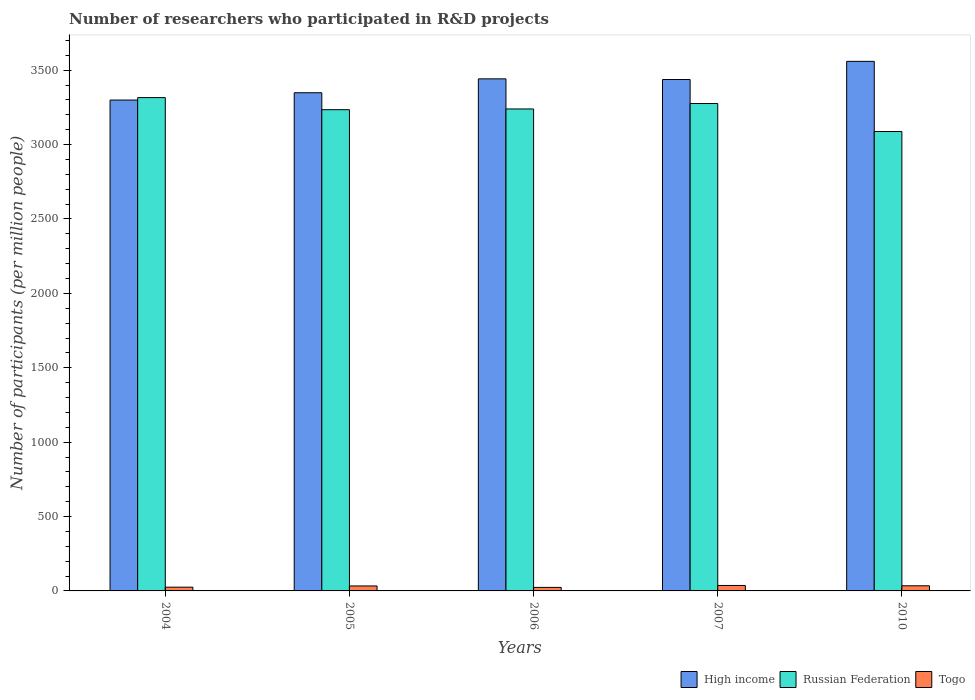How many different coloured bars are there?
Provide a succinct answer. 3. How many groups of bars are there?
Make the answer very short. 5. How many bars are there on the 5th tick from the left?
Give a very brief answer. 3. What is the label of the 1st group of bars from the left?
Make the answer very short. 2004. In how many cases, is the number of bars for a given year not equal to the number of legend labels?
Make the answer very short. 0. What is the number of researchers who participated in R&D projects in High income in 2006?
Provide a short and direct response. 3442.03. Across all years, what is the maximum number of researchers who participated in R&D projects in Togo?
Provide a short and direct response. 36.67. Across all years, what is the minimum number of researchers who participated in R&D projects in High income?
Keep it short and to the point. 3299.61. In which year was the number of researchers who participated in R&D projects in High income maximum?
Provide a short and direct response. 2010. In which year was the number of researchers who participated in R&D projects in Russian Federation minimum?
Provide a short and direct response. 2010. What is the total number of researchers who participated in R&D projects in Russian Federation in the graph?
Give a very brief answer. 1.62e+04. What is the difference between the number of researchers who participated in R&D projects in Togo in 2007 and that in 2010?
Provide a short and direct response. 2.2. What is the difference between the number of researchers who participated in R&D projects in Russian Federation in 2010 and the number of researchers who participated in R&D projects in High income in 2004?
Your answer should be compact. -211.62. What is the average number of researchers who participated in R&D projects in Russian Federation per year?
Your answer should be very brief. 3230.88. In the year 2004, what is the difference between the number of researchers who participated in R&D projects in Russian Federation and number of researchers who participated in R&D projects in Togo?
Give a very brief answer. 3290.74. What is the ratio of the number of researchers who participated in R&D projects in Togo in 2007 to that in 2010?
Keep it short and to the point. 1.06. What is the difference between the highest and the second highest number of researchers who participated in R&D projects in High income?
Offer a very short reply. 117.57. What is the difference between the highest and the lowest number of researchers who participated in R&D projects in High income?
Offer a terse response. 259.99. Is the sum of the number of researchers who participated in R&D projects in Russian Federation in 2005 and 2007 greater than the maximum number of researchers who participated in R&D projects in High income across all years?
Give a very brief answer. Yes. What does the 3rd bar from the left in 2004 represents?
Your answer should be very brief. Togo. Is it the case that in every year, the sum of the number of researchers who participated in R&D projects in High income and number of researchers who participated in R&D projects in Russian Federation is greater than the number of researchers who participated in R&D projects in Togo?
Provide a short and direct response. Yes. How many bars are there?
Offer a very short reply. 15. How many years are there in the graph?
Your answer should be compact. 5. What is the difference between two consecutive major ticks on the Y-axis?
Give a very brief answer. 500. Are the values on the major ticks of Y-axis written in scientific E-notation?
Your answer should be compact. No. How many legend labels are there?
Keep it short and to the point. 3. How are the legend labels stacked?
Your answer should be very brief. Horizontal. What is the title of the graph?
Your answer should be compact. Number of researchers who participated in R&D projects. Does "Pacific island small states" appear as one of the legend labels in the graph?
Provide a succinct answer. No. What is the label or title of the Y-axis?
Offer a terse response. Number of participants (per million people). What is the Number of participants (per million people) of High income in 2004?
Give a very brief answer. 3299.61. What is the Number of participants (per million people) in Russian Federation in 2004?
Your response must be concise. 3315.98. What is the Number of participants (per million people) of Togo in 2004?
Offer a terse response. 25.24. What is the Number of participants (per million people) of High income in 2005?
Your answer should be compact. 3348.65. What is the Number of participants (per million people) of Russian Federation in 2005?
Your answer should be very brief. 3234.71. What is the Number of participants (per million people) in Togo in 2005?
Keep it short and to the point. 33.34. What is the Number of participants (per million people) in High income in 2006?
Offer a very short reply. 3442.03. What is the Number of participants (per million people) in Russian Federation in 2006?
Give a very brief answer. 3239.59. What is the Number of participants (per million people) of Togo in 2006?
Offer a terse response. 23.73. What is the Number of participants (per million people) of High income in 2007?
Offer a very short reply. 3437.47. What is the Number of participants (per million people) of Russian Federation in 2007?
Ensure brevity in your answer.  3276.12. What is the Number of participants (per million people) of Togo in 2007?
Offer a very short reply. 36.67. What is the Number of participants (per million people) of High income in 2010?
Ensure brevity in your answer.  3559.6. What is the Number of participants (per million people) of Russian Federation in 2010?
Keep it short and to the point. 3087.99. What is the Number of participants (per million people) in Togo in 2010?
Offer a very short reply. 34.47. Across all years, what is the maximum Number of participants (per million people) in High income?
Your response must be concise. 3559.6. Across all years, what is the maximum Number of participants (per million people) of Russian Federation?
Your response must be concise. 3315.98. Across all years, what is the maximum Number of participants (per million people) of Togo?
Give a very brief answer. 36.67. Across all years, what is the minimum Number of participants (per million people) of High income?
Make the answer very short. 3299.61. Across all years, what is the minimum Number of participants (per million people) in Russian Federation?
Offer a very short reply. 3087.99. Across all years, what is the minimum Number of participants (per million people) of Togo?
Keep it short and to the point. 23.73. What is the total Number of participants (per million people) in High income in the graph?
Make the answer very short. 1.71e+04. What is the total Number of participants (per million people) of Russian Federation in the graph?
Give a very brief answer. 1.62e+04. What is the total Number of participants (per million people) in Togo in the graph?
Make the answer very short. 153.45. What is the difference between the Number of participants (per million people) in High income in 2004 and that in 2005?
Offer a terse response. -49.04. What is the difference between the Number of participants (per million people) of Russian Federation in 2004 and that in 2005?
Give a very brief answer. 81.27. What is the difference between the Number of participants (per million people) of Togo in 2004 and that in 2005?
Make the answer very short. -8.11. What is the difference between the Number of participants (per million people) in High income in 2004 and that in 2006?
Your answer should be compact. -142.42. What is the difference between the Number of participants (per million people) in Russian Federation in 2004 and that in 2006?
Keep it short and to the point. 76.4. What is the difference between the Number of participants (per million people) of Togo in 2004 and that in 2006?
Give a very brief answer. 1.51. What is the difference between the Number of participants (per million people) in High income in 2004 and that in 2007?
Ensure brevity in your answer.  -137.86. What is the difference between the Number of participants (per million people) in Russian Federation in 2004 and that in 2007?
Give a very brief answer. 39.86. What is the difference between the Number of participants (per million people) in Togo in 2004 and that in 2007?
Make the answer very short. -11.43. What is the difference between the Number of participants (per million people) of High income in 2004 and that in 2010?
Your response must be concise. -259.99. What is the difference between the Number of participants (per million people) of Russian Federation in 2004 and that in 2010?
Ensure brevity in your answer.  227.99. What is the difference between the Number of participants (per million people) of Togo in 2004 and that in 2010?
Your answer should be very brief. -9.23. What is the difference between the Number of participants (per million people) in High income in 2005 and that in 2006?
Offer a terse response. -93.37. What is the difference between the Number of participants (per million people) in Russian Federation in 2005 and that in 2006?
Your response must be concise. -4.88. What is the difference between the Number of participants (per million people) in Togo in 2005 and that in 2006?
Provide a short and direct response. 9.62. What is the difference between the Number of participants (per million people) of High income in 2005 and that in 2007?
Make the answer very short. -88.82. What is the difference between the Number of participants (per million people) of Russian Federation in 2005 and that in 2007?
Offer a very short reply. -41.41. What is the difference between the Number of participants (per million people) in Togo in 2005 and that in 2007?
Offer a terse response. -3.33. What is the difference between the Number of participants (per million people) in High income in 2005 and that in 2010?
Your answer should be compact. -210.95. What is the difference between the Number of participants (per million people) of Russian Federation in 2005 and that in 2010?
Ensure brevity in your answer.  146.72. What is the difference between the Number of participants (per million people) of Togo in 2005 and that in 2010?
Offer a terse response. -1.13. What is the difference between the Number of participants (per million people) of High income in 2006 and that in 2007?
Offer a very short reply. 4.56. What is the difference between the Number of participants (per million people) of Russian Federation in 2006 and that in 2007?
Your answer should be very brief. -36.54. What is the difference between the Number of participants (per million people) in Togo in 2006 and that in 2007?
Ensure brevity in your answer.  -12.94. What is the difference between the Number of participants (per million people) of High income in 2006 and that in 2010?
Your response must be concise. -117.57. What is the difference between the Number of participants (per million people) in Russian Federation in 2006 and that in 2010?
Offer a terse response. 151.59. What is the difference between the Number of participants (per million people) in Togo in 2006 and that in 2010?
Provide a short and direct response. -10.75. What is the difference between the Number of participants (per million people) of High income in 2007 and that in 2010?
Offer a very short reply. -122.13. What is the difference between the Number of participants (per million people) in Russian Federation in 2007 and that in 2010?
Ensure brevity in your answer.  188.13. What is the difference between the Number of participants (per million people) of Togo in 2007 and that in 2010?
Provide a succinct answer. 2.2. What is the difference between the Number of participants (per million people) of High income in 2004 and the Number of participants (per million people) of Russian Federation in 2005?
Your answer should be compact. 64.9. What is the difference between the Number of participants (per million people) in High income in 2004 and the Number of participants (per million people) in Togo in 2005?
Provide a short and direct response. 3266.27. What is the difference between the Number of participants (per million people) of Russian Federation in 2004 and the Number of participants (per million people) of Togo in 2005?
Ensure brevity in your answer.  3282.64. What is the difference between the Number of participants (per million people) of High income in 2004 and the Number of participants (per million people) of Russian Federation in 2006?
Ensure brevity in your answer.  60.03. What is the difference between the Number of participants (per million people) of High income in 2004 and the Number of participants (per million people) of Togo in 2006?
Offer a very short reply. 3275.89. What is the difference between the Number of participants (per million people) in Russian Federation in 2004 and the Number of participants (per million people) in Togo in 2006?
Ensure brevity in your answer.  3292.26. What is the difference between the Number of participants (per million people) in High income in 2004 and the Number of participants (per million people) in Russian Federation in 2007?
Ensure brevity in your answer.  23.49. What is the difference between the Number of participants (per million people) of High income in 2004 and the Number of participants (per million people) of Togo in 2007?
Ensure brevity in your answer.  3262.94. What is the difference between the Number of participants (per million people) of Russian Federation in 2004 and the Number of participants (per million people) of Togo in 2007?
Ensure brevity in your answer.  3279.31. What is the difference between the Number of participants (per million people) in High income in 2004 and the Number of participants (per million people) in Russian Federation in 2010?
Make the answer very short. 211.62. What is the difference between the Number of participants (per million people) of High income in 2004 and the Number of participants (per million people) of Togo in 2010?
Offer a terse response. 3265.14. What is the difference between the Number of participants (per million people) of Russian Federation in 2004 and the Number of participants (per million people) of Togo in 2010?
Make the answer very short. 3281.51. What is the difference between the Number of participants (per million people) of High income in 2005 and the Number of participants (per million people) of Russian Federation in 2006?
Your answer should be very brief. 109.07. What is the difference between the Number of participants (per million people) in High income in 2005 and the Number of participants (per million people) in Togo in 2006?
Ensure brevity in your answer.  3324.93. What is the difference between the Number of participants (per million people) in Russian Federation in 2005 and the Number of participants (per million people) in Togo in 2006?
Keep it short and to the point. 3210.98. What is the difference between the Number of participants (per million people) of High income in 2005 and the Number of participants (per million people) of Russian Federation in 2007?
Your response must be concise. 72.53. What is the difference between the Number of participants (per million people) of High income in 2005 and the Number of participants (per million people) of Togo in 2007?
Make the answer very short. 3311.98. What is the difference between the Number of participants (per million people) of Russian Federation in 2005 and the Number of participants (per million people) of Togo in 2007?
Your answer should be very brief. 3198.04. What is the difference between the Number of participants (per million people) of High income in 2005 and the Number of participants (per million people) of Russian Federation in 2010?
Keep it short and to the point. 260.66. What is the difference between the Number of participants (per million people) in High income in 2005 and the Number of participants (per million people) in Togo in 2010?
Provide a short and direct response. 3314.18. What is the difference between the Number of participants (per million people) of Russian Federation in 2005 and the Number of participants (per million people) of Togo in 2010?
Make the answer very short. 3200.24. What is the difference between the Number of participants (per million people) in High income in 2006 and the Number of participants (per million people) in Russian Federation in 2007?
Offer a terse response. 165.9. What is the difference between the Number of participants (per million people) in High income in 2006 and the Number of participants (per million people) in Togo in 2007?
Your answer should be very brief. 3405.36. What is the difference between the Number of participants (per million people) in Russian Federation in 2006 and the Number of participants (per million people) in Togo in 2007?
Your answer should be compact. 3202.92. What is the difference between the Number of participants (per million people) of High income in 2006 and the Number of participants (per million people) of Russian Federation in 2010?
Provide a succinct answer. 354.03. What is the difference between the Number of participants (per million people) of High income in 2006 and the Number of participants (per million people) of Togo in 2010?
Ensure brevity in your answer.  3407.56. What is the difference between the Number of participants (per million people) in Russian Federation in 2006 and the Number of participants (per million people) in Togo in 2010?
Provide a short and direct response. 3205.11. What is the difference between the Number of participants (per million people) in High income in 2007 and the Number of participants (per million people) in Russian Federation in 2010?
Your answer should be very brief. 349.48. What is the difference between the Number of participants (per million people) in High income in 2007 and the Number of participants (per million people) in Togo in 2010?
Ensure brevity in your answer.  3403. What is the difference between the Number of participants (per million people) of Russian Federation in 2007 and the Number of participants (per million people) of Togo in 2010?
Make the answer very short. 3241.65. What is the average Number of participants (per million people) of High income per year?
Ensure brevity in your answer.  3417.47. What is the average Number of participants (per million people) of Russian Federation per year?
Your answer should be very brief. 3230.88. What is the average Number of participants (per million people) of Togo per year?
Your answer should be very brief. 30.69. In the year 2004, what is the difference between the Number of participants (per million people) in High income and Number of participants (per million people) in Russian Federation?
Provide a succinct answer. -16.37. In the year 2004, what is the difference between the Number of participants (per million people) in High income and Number of participants (per million people) in Togo?
Give a very brief answer. 3274.37. In the year 2004, what is the difference between the Number of participants (per million people) of Russian Federation and Number of participants (per million people) of Togo?
Provide a succinct answer. 3290.74. In the year 2005, what is the difference between the Number of participants (per million people) in High income and Number of participants (per million people) in Russian Federation?
Provide a succinct answer. 113.95. In the year 2005, what is the difference between the Number of participants (per million people) of High income and Number of participants (per million people) of Togo?
Offer a terse response. 3315.31. In the year 2005, what is the difference between the Number of participants (per million people) in Russian Federation and Number of participants (per million people) in Togo?
Offer a terse response. 3201.36. In the year 2006, what is the difference between the Number of participants (per million people) in High income and Number of participants (per million people) in Russian Federation?
Provide a short and direct response. 202.44. In the year 2006, what is the difference between the Number of participants (per million people) of High income and Number of participants (per million people) of Togo?
Provide a succinct answer. 3418.3. In the year 2006, what is the difference between the Number of participants (per million people) of Russian Federation and Number of participants (per million people) of Togo?
Provide a succinct answer. 3215.86. In the year 2007, what is the difference between the Number of participants (per million people) of High income and Number of participants (per million people) of Russian Federation?
Your response must be concise. 161.35. In the year 2007, what is the difference between the Number of participants (per million people) of High income and Number of participants (per million people) of Togo?
Keep it short and to the point. 3400.8. In the year 2007, what is the difference between the Number of participants (per million people) of Russian Federation and Number of participants (per million people) of Togo?
Provide a short and direct response. 3239.45. In the year 2010, what is the difference between the Number of participants (per million people) in High income and Number of participants (per million people) in Russian Federation?
Provide a succinct answer. 471.61. In the year 2010, what is the difference between the Number of participants (per million people) of High income and Number of participants (per million people) of Togo?
Offer a very short reply. 3525.13. In the year 2010, what is the difference between the Number of participants (per million people) of Russian Federation and Number of participants (per million people) of Togo?
Ensure brevity in your answer.  3053.52. What is the ratio of the Number of participants (per million people) of High income in 2004 to that in 2005?
Your answer should be very brief. 0.99. What is the ratio of the Number of participants (per million people) of Russian Federation in 2004 to that in 2005?
Provide a short and direct response. 1.03. What is the ratio of the Number of participants (per million people) in Togo in 2004 to that in 2005?
Offer a terse response. 0.76. What is the ratio of the Number of participants (per million people) of High income in 2004 to that in 2006?
Your response must be concise. 0.96. What is the ratio of the Number of participants (per million people) of Russian Federation in 2004 to that in 2006?
Your response must be concise. 1.02. What is the ratio of the Number of participants (per million people) in Togo in 2004 to that in 2006?
Offer a terse response. 1.06. What is the ratio of the Number of participants (per million people) in High income in 2004 to that in 2007?
Your response must be concise. 0.96. What is the ratio of the Number of participants (per million people) in Russian Federation in 2004 to that in 2007?
Provide a succinct answer. 1.01. What is the ratio of the Number of participants (per million people) of Togo in 2004 to that in 2007?
Your answer should be very brief. 0.69. What is the ratio of the Number of participants (per million people) in High income in 2004 to that in 2010?
Make the answer very short. 0.93. What is the ratio of the Number of participants (per million people) of Russian Federation in 2004 to that in 2010?
Ensure brevity in your answer.  1.07. What is the ratio of the Number of participants (per million people) of Togo in 2004 to that in 2010?
Make the answer very short. 0.73. What is the ratio of the Number of participants (per million people) of High income in 2005 to that in 2006?
Ensure brevity in your answer.  0.97. What is the ratio of the Number of participants (per million people) in Togo in 2005 to that in 2006?
Provide a succinct answer. 1.41. What is the ratio of the Number of participants (per million people) in High income in 2005 to that in 2007?
Your answer should be compact. 0.97. What is the ratio of the Number of participants (per million people) of Russian Federation in 2005 to that in 2007?
Provide a short and direct response. 0.99. What is the ratio of the Number of participants (per million people) in Togo in 2005 to that in 2007?
Make the answer very short. 0.91. What is the ratio of the Number of participants (per million people) in High income in 2005 to that in 2010?
Your response must be concise. 0.94. What is the ratio of the Number of participants (per million people) in Russian Federation in 2005 to that in 2010?
Keep it short and to the point. 1.05. What is the ratio of the Number of participants (per million people) in Togo in 2005 to that in 2010?
Offer a very short reply. 0.97. What is the ratio of the Number of participants (per million people) of High income in 2006 to that in 2007?
Offer a terse response. 1. What is the ratio of the Number of participants (per million people) in Russian Federation in 2006 to that in 2007?
Provide a short and direct response. 0.99. What is the ratio of the Number of participants (per million people) of Togo in 2006 to that in 2007?
Offer a very short reply. 0.65. What is the ratio of the Number of participants (per million people) of High income in 2006 to that in 2010?
Provide a succinct answer. 0.97. What is the ratio of the Number of participants (per million people) of Russian Federation in 2006 to that in 2010?
Offer a very short reply. 1.05. What is the ratio of the Number of participants (per million people) in Togo in 2006 to that in 2010?
Provide a short and direct response. 0.69. What is the ratio of the Number of participants (per million people) of High income in 2007 to that in 2010?
Provide a short and direct response. 0.97. What is the ratio of the Number of participants (per million people) of Russian Federation in 2007 to that in 2010?
Keep it short and to the point. 1.06. What is the ratio of the Number of participants (per million people) of Togo in 2007 to that in 2010?
Give a very brief answer. 1.06. What is the difference between the highest and the second highest Number of participants (per million people) in High income?
Offer a terse response. 117.57. What is the difference between the highest and the second highest Number of participants (per million people) of Russian Federation?
Your response must be concise. 39.86. What is the difference between the highest and the second highest Number of participants (per million people) in Togo?
Ensure brevity in your answer.  2.2. What is the difference between the highest and the lowest Number of participants (per million people) of High income?
Give a very brief answer. 259.99. What is the difference between the highest and the lowest Number of participants (per million people) in Russian Federation?
Provide a succinct answer. 227.99. What is the difference between the highest and the lowest Number of participants (per million people) of Togo?
Ensure brevity in your answer.  12.94. 